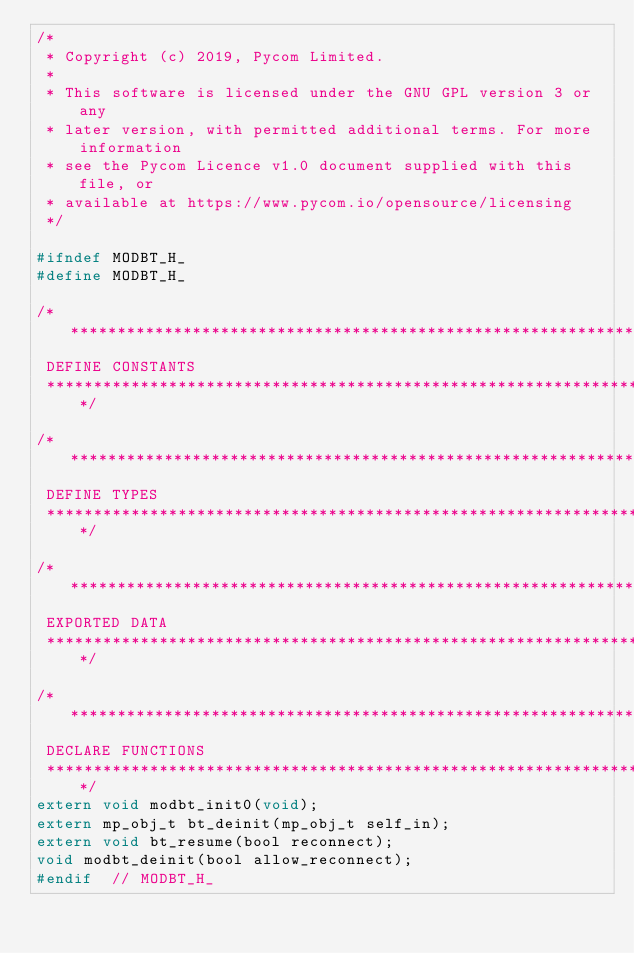<code> <loc_0><loc_0><loc_500><loc_500><_C_>/*
 * Copyright (c) 2019, Pycom Limited.
 *
 * This software is licensed under the GNU GPL version 3 or any
 * later version, with permitted additional terms. For more information
 * see the Pycom Licence v1.0 document supplied with this file, or
 * available at https://www.pycom.io/opensource/licensing
 */

#ifndef MODBT_H_
#define MODBT_H_

/******************************************************************************
 DEFINE CONSTANTS
 ******************************************************************************/

/******************************************************************************
 DEFINE TYPES
 ******************************************************************************/

/******************************************************************************
 EXPORTED DATA
 ******************************************************************************/

/******************************************************************************
 DECLARE FUNCTIONS
 ******************************************************************************/
extern void modbt_init0(void);
extern mp_obj_t bt_deinit(mp_obj_t self_in);
extern void bt_resume(bool reconnect);
void modbt_deinit(bool allow_reconnect);
#endif  // MODBT_H_
</code> 